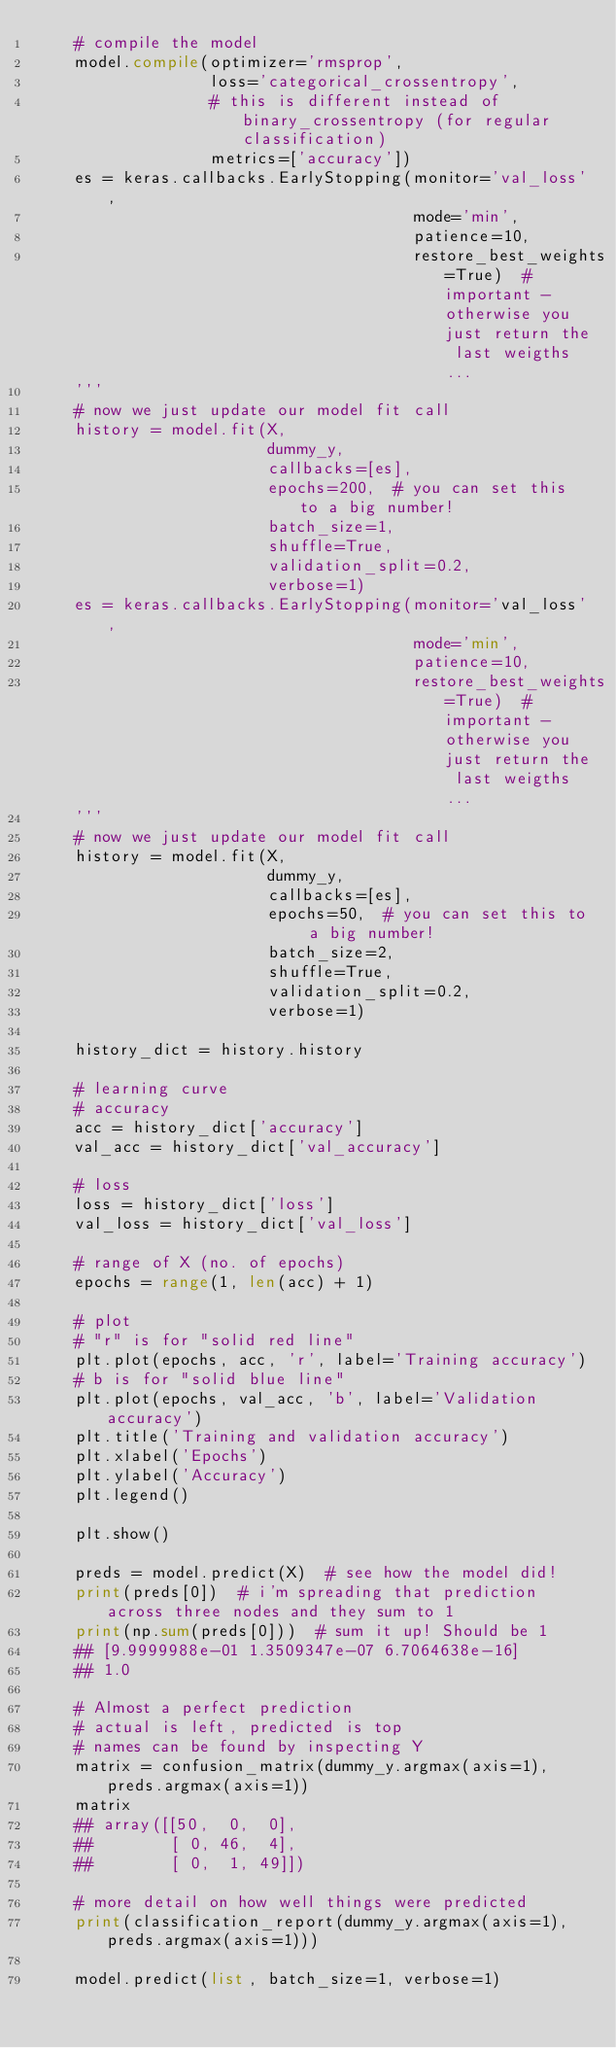<code> <loc_0><loc_0><loc_500><loc_500><_Python_>    # compile the model
    model.compile(optimizer='rmsprop',
                  loss='categorical_crossentropy',
                  # this is different instead of binary_crossentropy (for regular classification)
                  metrics=['accuracy'])
    es = keras.callbacks.EarlyStopping(monitor='val_loss',
                                       mode='min',
                                       patience=10,
                                       restore_best_weights=True)  # important - otherwise you just return the last weigths...
    '''
    # now we just update our model fit call
    history = model.fit(X,
                        dummy_y,
                        callbacks=[es],
                        epochs=200,  # you can set this to a big number!
                        batch_size=1,
                        shuffle=True,
                        validation_split=0.2,
                        verbose=1)
    es = keras.callbacks.EarlyStopping(monitor='val_loss',
                                       mode='min',
                                       patience=10,
                                       restore_best_weights=True)  # important - otherwise you just return the last weigths...
    '''
    # now we just update our model fit call
    history = model.fit(X,
                        dummy_y,
                        callbacks=[es],
                        epochs=50,  # you can set this to a big number!
                        batch_size=2,
                        shuffle=True,
                        validation_split=0.2,
                        verbose=1)

    history_dict = history.history

    # learning curve
    # accuracy
    acc = history_dict['accuracy']
    val_acc = history_dict['val_accuracy']

    # loss
    loss = history_dict['loss']
    val_loss = history_dict['val_loss']

    # range of X (no. of epochs)
    epochs = range(1, len(acc) + 1)

    # plot
    # "r" is for "solid red line"
    plt.plot(epochs, acc, 'r', label='Training accuracy')
    # b is for "solid blue line"
    plt.plot(epochs, val_acc, 'b', label='Validation accuracy')
    plt.title('Training and validation accuracy')
    plt.xlabel('Epochs')
    plt.ylabel('Accuracy')
    plt.legend()

    plt.show()

    preds = model.predict(X)  # see how the model did!
    print(preds[0])  # i'm spreading that prediction across three nodes and they sum to 1
    print(np.sum(preds[0]))  # sum it up! Should be 1
    ## [9.9999988e-01 1.3509347e-07 6.7064638e-16]
    ## 1.0

    # Almost a perfect prediction
    # actual is left, predicted is top
    # names can be found by inspecting Y
    matrix = confusion_matrix(dummy_y.argmax(axis=1), preds.argmax(axis=1))
    matrix
    ## array([[50,  0,  0],
    ##        [ 0, 46,  4],
    ##        [ 0,  1, 49]])

    # more detail on how well things were predicted
    print(classification_report(dummy_y.argmax(axis=1), preds.argmax(axis=1)))

    model.predict(list, batch_size=1, verbose=1)
</code> 